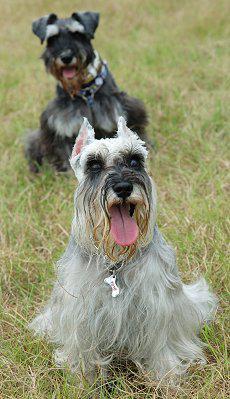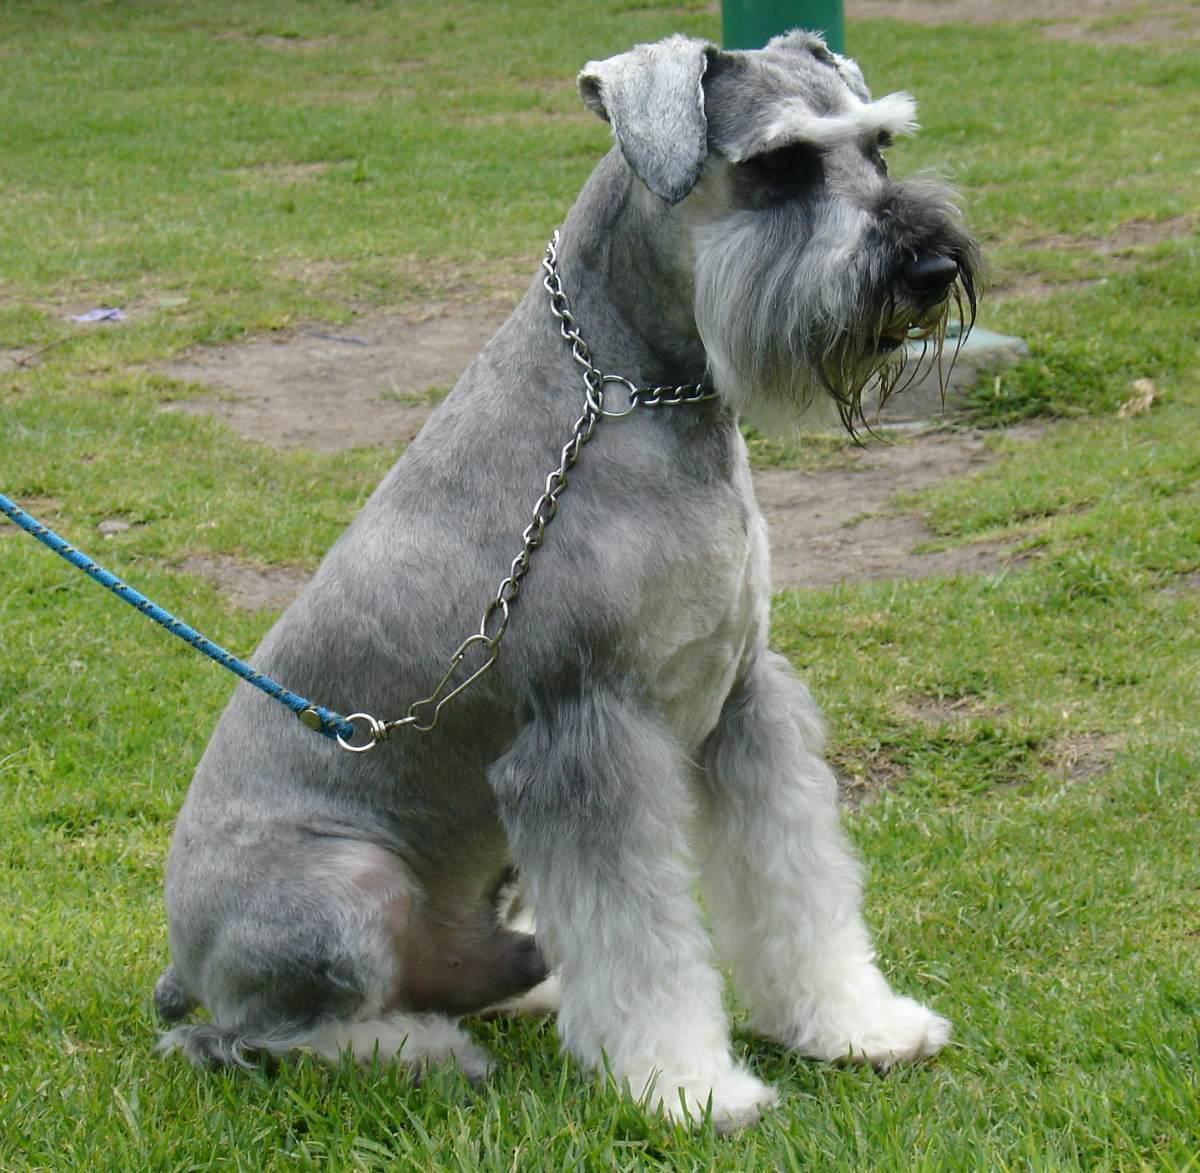The first image is the image on the left, the second image is the image on the right. For the images displayed, is the sentence "At least one dog has no visible collar on." factually correct? Answer yes or no. No. The first image is the image on the left, the second image is the image on the right. Assess this claim about the two images: "The dog in the right image is sitting on grass looking towards the right.". Correct or not? Answer yes or no. Yes. The first image is the image on the left, the second image is the image on the right. For the images shown, is this caption "At least one of the dogs is not outside." true? Answer yes or no. No. 